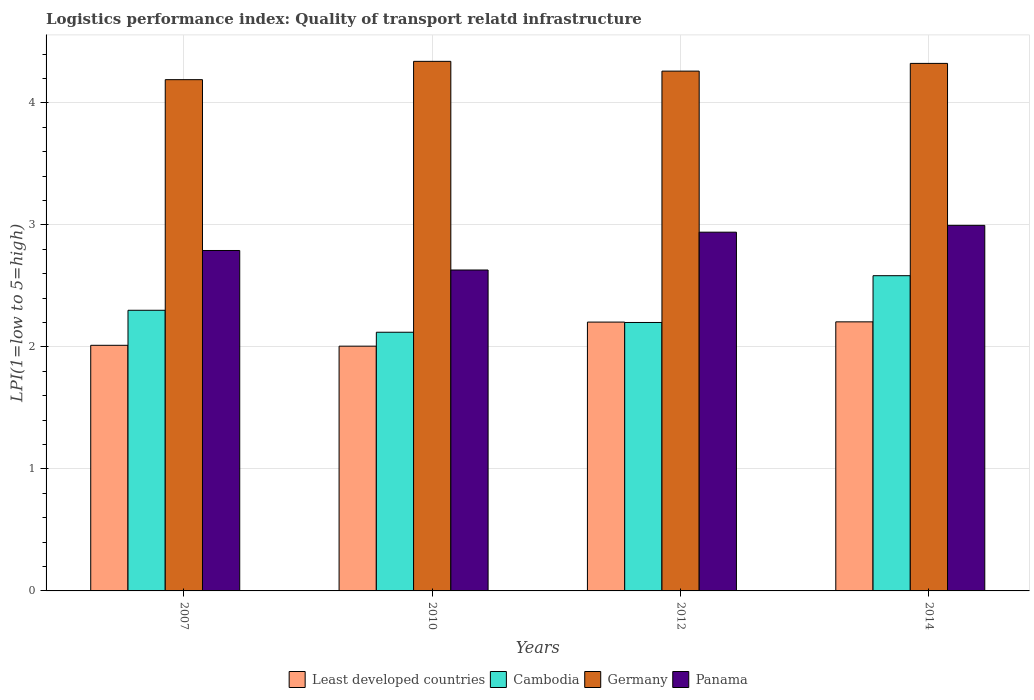How many bars are there on the 3rd tick from the right?
Your answer should be very brief. 4. What is the logistics performance index in Least developed countries in 2014?
Your answer should be very brief. 2.21. Across all years, what is the maximum logistics performance index in Least developed countries?
Your answer should be compact. 2.21. Across all years, what is the minimum logistics performance index in Least developed countries?
Your response must be concise. 2.01. What is the total logistics performance index in Least developed countries in the graph?
Provide a short and direct response. 8.43. What is the difference between the logistics performance index in Germany in 2012 and that in 2014?
Offer a very short reply. -0.06. What is the difference between the logistics performance index in Panama in 2007 and the logistics performance index in Germany in 2010?
Make the answer very short. -1.55. What is the average logistics performance index in Germany per year?
Your answer should be compact. 4.28. In the year 2014, what is the difference between the logistics performance index in Germany and logistics performance index in Cambodia?
Provide a short and direct response. 1.74. What is the ratio of the logistics performance index in Panama in 2012 to that in 2014?
Offer a terse response. 0.98. Is the difference between the logistics performance index in Germany in 2010 and 2014 greater than the difference between the logistics performance index in Cambodia in 2010 and 2014?
Give a very brief answer. Yes. What is the difference between the highest and the second highest logistics performance index in Cambodia?
Offer a very short reply. 0.28. What is the difference between the highest and the lowest logistics performance index in Least developed countries?
Ensure brevity in your answer.  0.2. In how many years, is the logistics performance index in Cambodia greater than the average logistics performance index in Cambodia taken over all years?
Offer a terse response. 1. Is the sum of the logistics performance index in Least developed countries in 2012 and 2014 greater than the maximum logistics performance index in Cambodia across all years?
Keep it short and to the point. Yes. Is it the case that in every year, the sum of the logistics performance index in Cambodia and logistics performance index in Panama is greater than the sum of logistics performance index in Germany and logistics performance index in Least developed countries?
Your answer should be compact. Yes. What does the 2nd bar from the left in 2007 represents?
Offer a very short reply. Cambodia. What does the 3rd bar from the right in 2010 represents?
Provide a short and direct response. Cambodia. Is it the case that in every year, the sum of the logistics performance index in Least developed countries and logistics performance index in Cambodia is greater than the logistics performance index in Germany?
Your answer should be compact. No. How many bars are there?
Make the answer very short. 16. Are all the bars in the graph horizontal?
Your answer should be very brief. No. Are the values on the major ticks of Y-axis written in scientific E-notation?
Make the answer very short. No. Does the graph contain grids?
Keep it short and to the point. Yes. How are the legend labels stacked?
Keep it short and to the point. Horizontal. What is the title of the graph?
Give a very brief answer. Logistics performance index: Quality of transport relatd infrastructure. What is the label or title of the Y-axis?
Your answer should be compact. LPI(1=low to 5=high). What is the LPI(1=low to 5=high) of Least developed countries in 2007?
Your response must be concise. 2.01. What is the LPI(1=low to 5=high) in Cambodia in 2007?
Your answer should be very brief. 2.3. What is the LPI(1=low to 5=high) in Germany in 2007?
Provide a succinct answer. 4.19. What is the LPI(1=low to 5=high) in Panama in 2007?
Provide a succinct answer. 2.79. What is the LPI(1=low to 5=high) of Least developed countries in 2010?
Ensure brevity in your answer.  2.01. What is the LPI(1=low to 5=high) of Cambodia in 2010?
Your answer should be very brief. 2.12. What is the LPI(1=low to 5=high) of Germany in 2010?
Your answer should be compact. 4.34. What is the LPI(1=low to 5=high) in Panama in 2010?
Provide a succinct answer. 2.63. What is the LPI(1=low to 5=high) in Least developed countries in 2012?
Your answer should be compact. 2.2. What is the LPI(1=low to 5=high) of Germany in 2012?
Offer a terse response. 4.26. What is the LPI(1=low to 5=high) in Panama in 2012?
Give a very brief answer. 2.94. What is the LPI(1=low to 5=high) of Least developed countries in 2014?
Give a very brief answer. 2.21. What is the LPI(1=low to 5=high) in Cambodia in 2014?
Provide a short and direct response. 2.58. What is the LPI(1=low to 5=high) in Germany in 2014?
Give a very brief answer. 4.32. What is the LPI(1=low to 5=high) in Panama in 2014?
Give a very brief answer. 3. Across all years, what is the maximum LPI(1=low to 5=high) in Least developed countries?
Keep it short and to the point. 2.21. Across all years, what is the maximum LPI(1=low to 5=high) of Cambodia?
Offer a terse response. 2.58. Across all years, what is the maximum LPI(1=low to 5=high) in Germany?
Provide a succinct answer. 4.34. Across all years, what is the maximum LPI(1=low to 5=high) of Panama?
Offer a very short reply. 3. Across all years, what is the minimum LPI(1=low to 5=high) of Least developed countries?
Keep it short and to the point. 2.01. Across all years, what is the minimum LPI(1=low to 5=high) of Cambodia?
Keep it short and to the point. 2.12. Across all years, what is the minimum LPI(1=low to 5=high) of Germany?
Offer a terse response. 4.19. Across all years, what is the minimum LPI(1=low to 5=high) of Panama?
Offer a very short reply. 2.63. What is the total LPI(1=low to 5=high) in Least developed countries in the graph?
Provide a short and direct response. 8.43. What is the total LPI(1=low to 5=high) in Cambodia in the graph?
Ensure brevity in your answer.  9.2. What is the total LPI(1=low to 5=high) of Germany in the graph?
Your answer should be compact. 17.11. What is the total LPI(1=low to 5=high) in Panama in the graph?
Offer a very short reply. 11.36. What is the difference between the LPI(1=low to 5=high) in Least developed countries in 2007 and that in 2010?
Give a very brief answer. 0.01. What is the difference between the LPI(1=low to 5=high) of Cambodia in 2007 and that in 2010?
Provide a short and direct response. 0.18. What is the difference between the LPI(1=low to 5=high) in Germany in 2007 and that in 2010?
Your answer should be compact. -0.15. What is the difference between the LPI(1=low to 5=high) of Panama in 2007 and that in 2010?
Give a very brief answer. 0.16. What is the difference between the LPI(1=low to 5=high) in Least developed countries in 2007 and that in 2012?
Your answer should be very brief. -0.19. What is the difference between the LPI(1=low to 5=high) of Germany in 2007 and that in 2012?
Provide a succinct answer. -0.07. What is the difference between the LPI(1=low to 5=high) of Panama in 2007 and that in 2012?
Ensure brevity in your answer.  -0.15. What is the difference between the LPI(1=low to 5=high) in Least developed countries in 2007 and that in 2014?
Provide a succinct answer. -0.19. What is the difference between the LPI(1=low to 5=high) of Cambodia in 2007 and that in 2014?
Offer a very short reply. -0.28. What is the difference between the LPI(1=low to 5=high) of Germany in 2007 and that in 2014?
Make the answer very short. -0.13. What is the difference between the LPI(1=low to 5=high) of Panama in 2007 and that in 2014?
Your response must be concise. -0.21. What is the difference between the LPI(1=low to 5=high) of Least developed countries in 2010 and that in 2012?
Your answer should be compact. -0.2. What is the difference between the LPI(1=low to 5=high) of Cambodia in 2010 and that in 2012?
Your response must be concise. -0.08. What is the difference between the LPI(1=low to 5=high) in Panama in 2010 and that in 2012?
Offer a very short reply. -0.31. What is the difference between the LPI(1=low to 5=high) of Least developed countries in 2010 and that in 2014?
Offer a very short reply. -0.2. What is the difference between the LPI(1=low to 5=high) of Cambodia in 2010 and that in 2014?
Give a very brief answer. -0.46. What is the difference between the LPI(1=low to 5=high) of Germany in 2010 and that in 2014?
Make the answer very short. 0.02. What is the difference between the LPI(1=low to 5=high) in Panama in 2010 and that in 2014?
Keep it short and to the point. -0.37. What is the difference between the LPI(1=low to 5=high) of Least developed countries in 2012 and that in 2014?
Offer a terse response. -0. What is the difference between the LPI(1=low to 5=high) of Cambodia in 2012 and that in 2014?
Your answer should be very brief. -0.38. What is the difference between the LPI(1=low to 5=high) of Germany in 2012 and that in 2014?
Provide a short and direct response. -0.06. What is the difference between the LPI(1=low to 5=high) of Panama in 2012 and that in 2014?
Ensure brevity in your answer.  -0.06. What is the difference between the LPI(1=low to 5=high) of Least developed countries in 2007 and the LPI(1=low to 5=high) of Cambodia in 2010?
Make the answer very short. -0.11. What is the difference between the LPI(1=low to 5=high) in Least developed countries in 2007 and the LPI(1=low to 5=high) in Germany in 2010?
Ensure brevity in your answer.  -2.33. What is the difference between the LPI(1=low to 5=high) in Least developed countries in 2007 and the LPI(1=low to 5=high) in Panama in 2010?
Keep it short and to the point. -0.62. What is the difference between the LPI(1=low to 5=high) of Cambodia in 2007 and the LPI(1=low to 5=high) of Germany in 2010?
Make the answer very short. -2.04. What is the difference between the LPI(1=low to 5=high) of Cambodia in 2007 and the LPI(1=low to 5=high) of Panama in 2010?
Offer a terse response. -0.33. What is the difference between the LPI(1=low to 5=high) of Germany in 2007 and the LPI(1=low to 5=high) of Panama in 2010?
Offer a very short reply. 1.56. What is the difference between the LPI(1=low to 5=high) of Least developed countries in 2007 and the LPI(1=low to 5=high) of Cambodia in 2012?
Offer a terse response. -0.19. What is the difference between the LPI(1=low to 5=high) of Least developed countries in 2007 and the LPI(1=low to 5=high) of Germany in 2012?
Provide a short and direct response. -2.25. What is the difference between the LPI(1=low to 5=high) in Least developed countries in 2007 and the LPI(1=low to 5=high) in Panama in 2012?
Give a very brief answer. -0.93. What is the difference between the LPI(1=low to 5=high) in Cambodia in 2007 and the LPI(1=low to 5=high) in Germany in 2012?
Your answer should be compact. -1.96. What is the difference between the LPI(1=low to 5=high) of Cambodia in 2007 and the LPI(1=low to 5=high) of Panama in 2012?
Provide a short and direct response. -0.64. What is the difference between the LPI(1=low to 5=high) of Germany in 2007 and the LPI(1=low to 5=high) of Panama in 2012?
Provide a short and direct response. 1.25. What is the difference between the LPI(1=low to 5=high) in Least developed countries in 2007 and the LPI(1=low to 5=high) in Cambodia in 2014?
Give a very brief answer. -0.57. What is the difference between the LPI(1=low to 5=high) in Least developed countries in 2007 and the LPI(1=low to 5=high) in Germany in 2014?
Offer a terse response. -2.31. What is the difference between the LPI(1=low to 5=high) of Least developed countries in 2007 and the LPI(1=low to 5=high) of Panama in 2014?
Your answer should be very brief. -0.98. What is the difference between the LPI(1=low to 5=high) in Cambodia in 2007 and the LPI(1=low to 5=high) in Germany in 2014?
Offer a very short reply. -2.02. What is the difference between the LPI(1=low to 5=high) in Cambodia in 2007 and the LPI(1=low to 5=high) in Panama in 2014?
Make the answer very short. -0.7. What is the difference between the LPI(1=low to 5=high) in Germany in 2007 and the LPI(1=low to 5=high) in Panama in 2014?
Offer a terse response. 1.19. What is the difference between the LPI(1=low to 5=high) in Least developed countries in 2010 and the LPI(1=low to 5=high) in Cambodia in 2012?
Your response must be concise. -0.19. What is the difference between the LPI(1=low to 5=high) in Least developed countries in 2010 and the LPI(1=low to 5=high) in Germany in 2012?
Ensure brevity in your answer.  -2.25. What is the difference between the LPI(1=low to 5=high) of Least developed countries in 2010 and the LPI(1=low to 5=high) of Panama in 2012?
Provide a succinct answer. -0.93. What is the difference between the LPI(1=low to 5=high) in Cambodia in 2010 and the LPI(1=low to 5=high) in Germany in 2012?
Make the answer very short. -2.14. What is the difference between the LPI(1=low to 5=high) of Cambodia in 2010 and the LPI(1=low to 5=high) of Panama in 2012?
Give a very brief answer. -0.82. What is the difference between the LPI(1=low to 5=high) of Least developed countries in 2010 and the LPI(1=low to 5=high) of Cambodia in 2014?
Your answer should be very brief. -0.58. What is the difference between the LPI(1=low to 5=high) of Least developed countries in 2010 and the LPI(1=low to 5=high) of Germany in 2014?
Provide a short and direct response. -2.32. What is the difference between the LPI(1=low to 5=high) in Least developed countries in 2010 and the LPI(1=low to 5=high) in Panama in 2014?
Offer a terse response. -0.99. What is the difference between the LPI(1=low to 5=high) of Cambodia in 2010 and the LPI(1=low to 5=high) of Germany in 2014?
Ensure brevity in your answer.  -2.2. What is the difference between the LPI(1=low to 5=high) in Cambodia in 2010 and the LPI(1=low to 5=high) in Panama in 2014?
Make the answer very short. -0.88. What is the difference between the LPI(1=low to 5=high) of Germany in 2010 and the LPI(1=low to 5=high) of Panama in 2014?
Give a very brief answer. 1.34. What is the difference between the LPI(1=low to 5=high) of Least developed countries in 2012 and the LPI(1=low to 5=high) of Cambodia in 2014?
Offer a very short reply. -0.38. What is the difference between the LPI(1=low to 5=high) of Least developed countries in 2012 and the LPI(1=low to 5=high) of Germany in 2014?
Your answer should be very brief. -2.12. What is the difference between the LPI(1=low to 5=high) of Least developed countries in 2012 and the LPI(1=low to 5=high) of Panama in 2014?
Your response must be concise. -0.79. What is the difference between the LPI(1=low to 5=high) in Cambodia in 2012 and the LPI(1=low to 5=high) in Germany in 2014?
Keep it short and to the point. -2.12. What is the difference between the LPI(1=low to 5=high) in Cambodia in 2012 and the LPI(1=low to 5=high) in Panama in 2014?
Offer a terse response. -0.8. What is the difference between the LPI(1=low to 5=high) of Germany in 2012 and the LPI(1=low to 5=high) of Panama in 2014?
Keep it short and to the point. 1.26. What is the average LPI(1=low to 5=high) of Least developed countries per year?
Provide a short and direct response. 2.11. What is the average LPI(1=low to 5=high) in Cambodia per year?
Give a very brief answer. 2.3. What is the average LPI(1=low to 5=high) of Germany per year?
Give a very brief answer. 4.28. What is the average LPI(1=low to 5=high) in Panama per year?
Your answer should be very brief. 2.84. In the year 2007, what is the difference between the LPI(1=low to 5=high) of Least developed countries and LPI(1=low to 5=high) of Cambodia?
Ensure brevity in your answer.  -0.29. In the year 2007, what is the difference between the LPI(1=low to 5=high) in Least developed countries and LPI(1=low to 5=high) in Germany?
Make the answer very short. -2.18. In the year 2007, what is the difference between the LPI(1=low to 5=high) in Least developed countries and LPI(1=low to 5=high) in Panama?
Offer a very short reply. -0.78. In the year 2007, what is the difference between the LPI(1=low to 5=high) in Cambodia and LPI(1=low to 5=high) in Germany?
Ensure brevity in your answer.  -1.89. In the year 2007, what is the difference between the LPI(1=low to 5=high) of Cambodia and LPI(1=low to 5=high) of Panama?
Provide a succinct answer. -0.49. In the year 2010, what is the difference between the LPI(1=low to 5=high) in Least developed countries and LPI(1=low to 5=high) in Cambodia?
Keep it short and to the point. -0.11. In the year 2010, what is the difference between the LPI(1=low to 5=high) in Least developed countries and LPI(1=low to 5=high) in Germany?
Offer a very short reply. -2.33. In the year 2010, what is the difference between the LPI(1=low to 5=high) of Least developed countries and LPI(1=low to 5=high) of Panama?
Give a very brief answer. -0.62. In the year 2010, what is the difference between the LPI(1=low to 5=high) in Cambodia and LPI(1=low to 5=high) in Germany?
Ensure brevity in your answer.  -2.22. In the year 2010, what is the difference between the LPI(1=low to 5=high) of Cambodia and LPI(1=low to 5=high) of Panama?
Your answer should be very brief. -0.51. In the year 2010, what is the difference between the LPI(1=low to 5=high) in Germany and LPI(1=low to 5=high) in Panama?
Your answer should be compact. 1.71. In the year 2012, what is the difference between the LPI(1=low to 5=high) in Least developed countries and LPI(1=low to 5=high) in Cambodia?
Your response must be concise. 0. In the year 2012, what is the difference between the LPI(1=low to 5=high) in Least developed countries and LPI(1=low to 5=high) in Germany?
Your answer should be compact. -2.06. In the year 2012, what is the difference between the LPI(1=low to 5=high) of Least developed countries and LPI(1=low to 5=high) of Panama?
Your answer should be compact. -0.74. In the year 2012, what is the difference between the LPI(1=low to 5=high) in Cambodia and LPI(1=low to 5=high) in Germany?
Provide a short and direct response. -2.06. In the year 2012, what is the difference between the LPI(1=low to 5=high) of Cambodia and LPI(1=low to 5=high) of Panama?
Your response must be concise. -0.74. In the year 2012, what is the difference between the LPI(1=low to 5=high) in Germany and LPI(1=low to 5=high) in Panama?
Offer a terse response. 1.32. In the year 2014, what is the difference between the LPI(1=low to 5=high) in Least developed countries and LPI(1=low to 5=high) in Cambodia?
Your answer should be compact. -0.38. In the year 2014, what is the difference between the LPI(1=low to 5=high) of Least developed countries and LPI(1=low to 5=high) of Germany?
Ensure brevity in your answer.  -2.12. In the year 2014, what is the difference between the LPI(1=low to 5=high) in Least developed countries and LPI(1=low to 5=high) in Panama?
Your answer should be very brief. -0.79. In the year 2014, what is the difference between the LPI(1=low to 5=high) in Cambodia and LPI(1=low to 5=high) in Germany?
Provide a short and direct response. -1.74. In the year 2014, what is the difference between the LPI(1=low to 5=high) of Cambodia and LPI(1=low to 5=high) of Panama?
Provide a short and direct response. -0.41. In the year 2014, what is the difference between the LPI(1=low to 5=high) of Germany and LPI(1=low to 5=high) of Panama?
Provide a short and direct response. 1.33. What is the ratio of the LPI(1=low to 5=high) in Least developed countries in 2007 to that in 2010?
Your answer should be very brief. 1. What is the ratio of the LPI(1=low to 5=high) of Cambodia in 2007 to that in 2010?
Your response must be concise. 1.08. What is the ratio of the LPI(1=low to 5=high) of Germany in 2007 to that in 2010?
Ensure brevity in your answer.  0.97. What is the ratio of the LPI(1=low to 5=high) in Panama in 2007 to that in 2010?
Make the answer very short. 1.06. What is the ratio of the LPI(1=low to 5=high) of Least developed countries in 2007 to that in 2012?
Your answer should be very brief. 0.91. What is the ratio of the LPI(1=low to 5=high) of Cambodia in 2007 to that in 2012?
Your answer should be compact. 1.05. What is the ratio of the LPI(1=low to 5=high) of Germany in 2007 to that in 2012?
Offer a very short reply. 0.98. What is the ratio of the LPI(1=low to 5=high) of Panama in 2007 to that in 2012?
Ensure brevity in your answer.  0.95. What is the ratio of the LPI(1=low to 5=high) in Least developed countries in 2007 to that in 2014?
Provide a short and direct response. 0.91. What is the ratio of the LPI(1=low to 5=high) in Cambodia in 2007 to that in 2014?
Your response must be concise. 0.89. What is the ratio of the LPI(1=low to 5=high) in Germany in 2007 to that in 2014?
Make the answer very short. 0.97. What is the ratio of the LPI(1=low to 5=high) of Panama in 2007 to that in 2014?
Your response must be concise. 0.93. What is the ratio of the LPI(1=low to 5=high) in Least developed countries in 2010 to that in 2012?
Your answer should be compact. 0.91. What is the ratio of the LPI(1=low to 5=high) in Cambodia in 2010 to that in 2012?
Make the answer very short. 0.96. What is the ratio of the LPI(1=low to 5=high) in Germany in 2010 to that in 2012?
Make the answer very short. 1.02. What is the ratio of the LPI(1=low to 5=high) of Panama in 2010 to that in 2012?
Ensure brevity in your answer.  0.89. What is the ratio of the LPI(1=low to 5=high) in Least developed countries in 2010 to that in 2014?
Keep it short and to the point. 0.91. What is the ratio of the LPI(1=low to 5=high) of Cambodia in 2010 to that in 2014?
Your answer should be very brief. 0.82. What is the ratio of the LPI(1=low to 5=high) of Germany in 2010 to that in 2014?
Provide a succinct answer. 1. What is the ratio of the LPI(1=low to 5=high) in Panama in 2010 to that in 2014?
Your answer should be compact. 0.88. What is the ratio of the LPI(1=low to 5=high) in Least developed countries in 2012 to that in 2014?
Provide a succinct answer. 1. What is the ratio of the LPI(1=low to 5=high) of Cambodia in 2012 to that in 2014?
Your answer should be very brief. 0.85. What is the ratio of the LPI(1=low to 5=high) of Germany in 2012 to that in 2014?
Give a very brief answer. 0.99. What is the ratio of the LPI(1=low to 5=high) in Panama in 2012 to that in 2014?
Your answer should be compact. 0.98. What is the difference between the highest and the second highest LPI(1=low to 5=high) in Least developed countries?
Your response must be concise. 0. What is the difference between the highest and the second highest LPI(1=low to 5=high) of Cambodia?
Your response must be concise. 0.28. What is the difference between the highest and the second highest LPI(1=low to 5=high) of Germany?
Keep it short and to the point. 0.02. What is the difference between the highest and the second highest LPI(1=low to 5=high) in Panama?
Ensure brevity in your answer.  0.06. What is the difference between the highest and the lowest LPI(1=low to 5=high) of Least developed countries?
Offer a very short reply. 0.2. What is the difference between the highest and the lowest LPI(1=low to 5=high) in Cambodia?
Provide a short and direct response. 0.46. What is the difference between the highest and the lowest LPI(1=low to 5=high) in Panama?
Your answer should be compact. 0.37. 